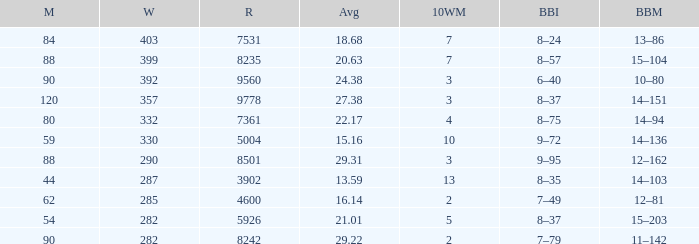How many wickets have runs under 7531, matches over 44, and an average of 22.17? 332.0. 